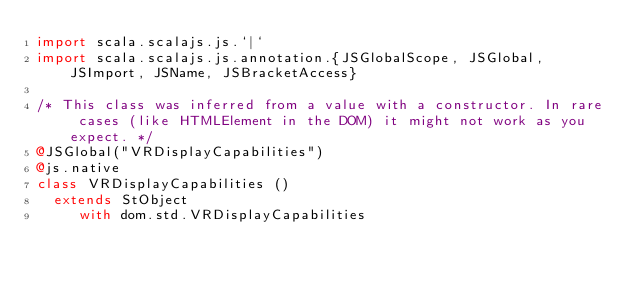Convert code to text. <code><loc_0><loc_0><loc_500><loc_500><_Scala_>import scala.scalajs.js.`|`
import scala.scalajs.js.annotation.{JSGlobalScope, JSGlobal, JSImport, JSName, JSBracketAccess}

/* This class was inferred from a value with a constructor. In rare cases (like HTMLElement in the DOM) it might not work as you expect. */
@JSGlobal("VRDisplayCapabilities")
@js.native
class VRDisplayCapabilities ()
  extends StObject
     with dom.std.VRDisplayCapabilities
</code> 